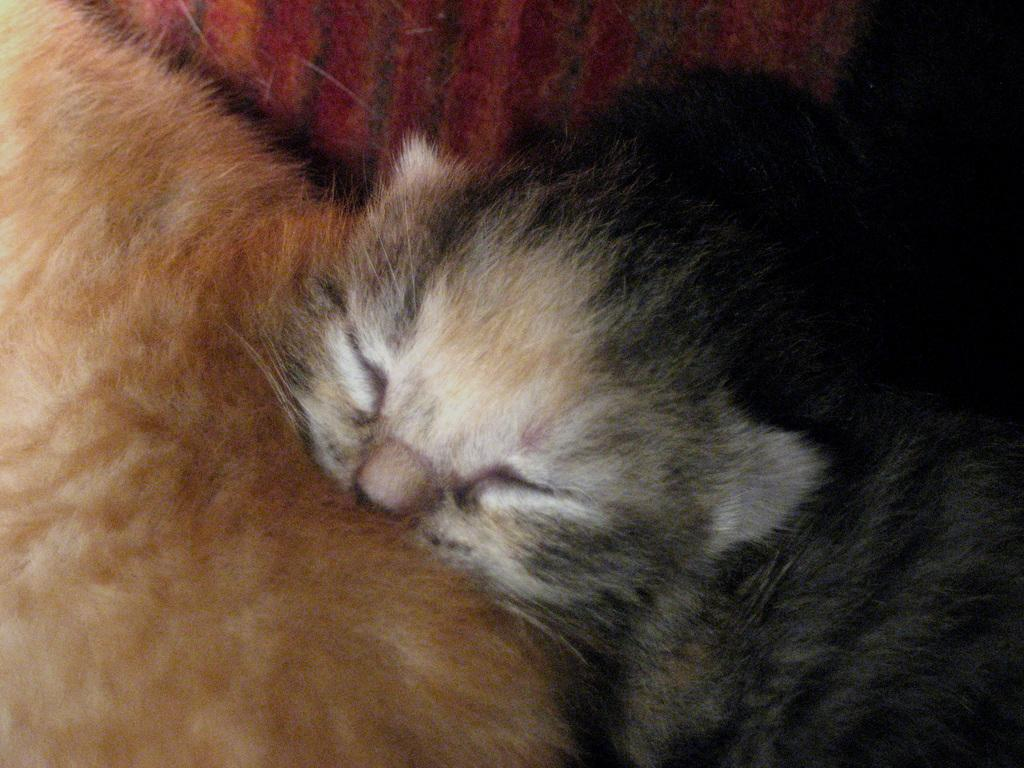What type of animals are in the image? There are cats in the image. What colors are the cats? The cats are white, light brown, and gray in color. What are the cats feeling in the image? The image does not provide information about the cats' feelings, so it cannot be determined from the image. 